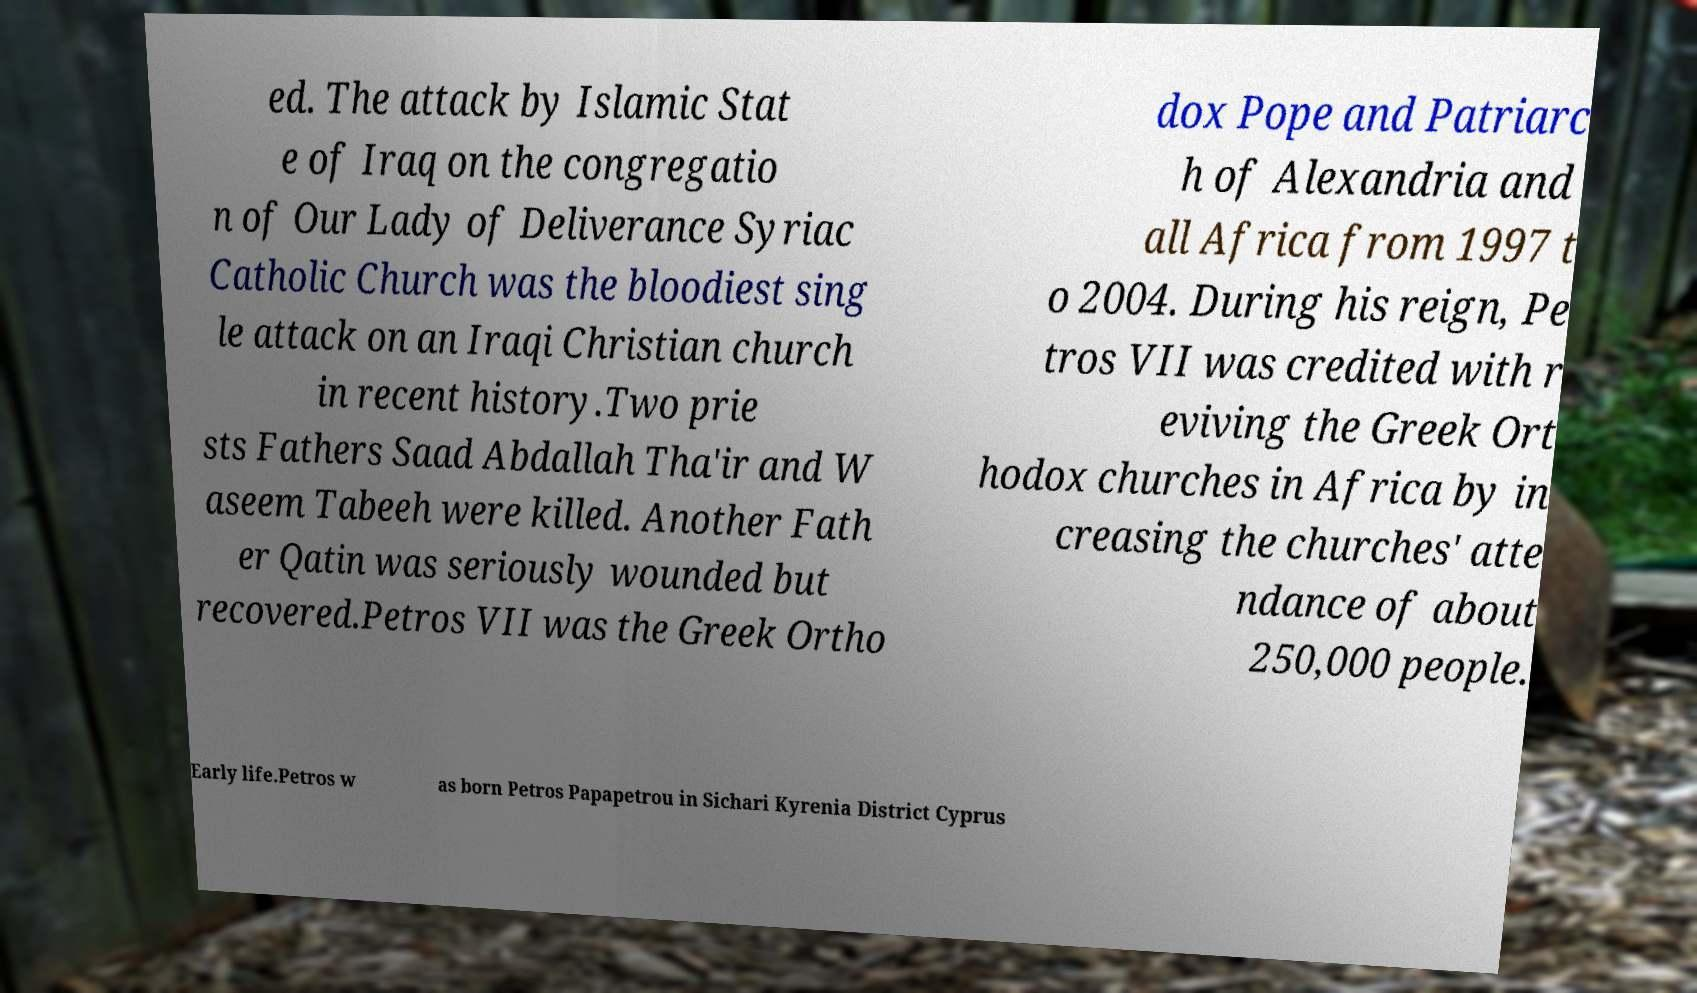Can you accurately transcribe the text from the provided image for me? ed. The attack by Islamic Stat e of Iraq on the congregatio n of Our Lady of Deliverance Syriac Catholic Church was the bloodiest sing le attack on an Iraqi Christian church in recent history.Two prie sts Fathers Saad Abdallah Tha'ir and W aseem Tabeeh were killed. Another Fath er Qatin was seriously wounded but recovered.Petros VII was the Greek Ortho dox Pope and Patriarc h of Alexandria and all Africa from 1997 t o 2004. During his reign, Pe tros VII was credited with r eviving the Greek Ort hodox churches in Africa by in creasing the churches' atte ndance of about 250,000 people. Early life.Petros w as born Petros Papapetrou in Sichari Kyrenia District Cyprus 